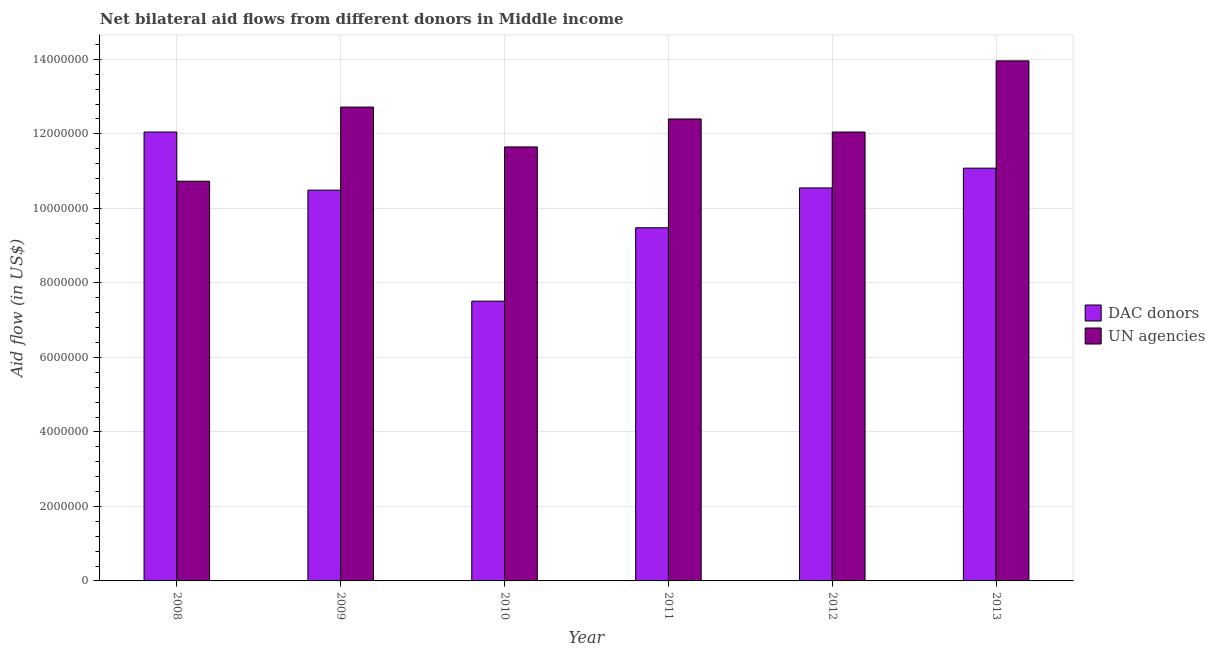Are the number of bars per tick equal to the number of legend labels?
Your answer should be compact. Yes. Are the number of bars on each tick of the X-axis equal?
Make the answer very short. Yes. How many bars are there on the 3rd tick from the left?
Your response must be concise. 2. In how many cases, is the number of bars for a given year not equal to the number of legend labels?
Your answer should be compact. 0. What is the aid flow from dac donors in 2008?
Your response must be concise. 1.20e+07. Across all years, what is the maximum aid flow from un agencies?
Offer a very short reply. 1.40e+07. Across all years, what is the minimum aid flow from dac donors?
Ensure brevity in your answer.  7.51e+06. In which year was the aid flow from un agencies maximum?
Your answer should be compact. 2013. In which year was the aid flow from un agencies minimum?
Provide a succinct answer. 2008. What is the total aid flow from dac donors in the graph?
Your response must be concise. 6.12e+07. What is the difference between the aid flow from un agencies in 2008 and that in 2010?
Offer a very short reply. -9.20e+05. What is the difference between the aid flow from dac donors in 2013 and the aid flow from un agencies in 2012?
Your answer should be very brief. 5.30e+05. What is the average aid flow from un agencies per year?
Provide a succinct answer. 1.23e+07. In the year 2012, what is the difference between the aid flow from dac donors and aid flow from un agencies?
Ensure brevity in your answer.  0. What is the ratio of the aid flow from un agencies in 2011 to that in 2013?
Offer a terse response. 0.89. Is the aid flow from dac donors in 2011 less than that in 2012?
Your response must be concise. Yes. What is the difference between the highest and the second highest aid flow from dac donors?
Provide a succinct answer. 9.70e+05. What is the difference between the highest and the lowest aid flow from dac donors?
Keep it short and to the point. 4.54e+06. In how many years, is the aid flow from dac donors greater than the average aid flow from dac donors taken over all years?
Your response must be concise. 4. Is the sum of the aid flow from un agencies in 2012 and 2013 greater than the maximum aid flow from dac donors across all years?
Offer a terse response. Yes. What does the 2nd bar from the left in 2011 represents?
Offer a terse response. UN agencies. What does the 1st bar from the right in 2009 represents?
Ensure brevity in your answer.  UN agencies. How many bars are there?
Keep it short and to the point. 12. Are all the bars in the graph horizontal?
Your answer should be compact. No. Where does the legend appear in the graph?
Offer a terse response. Center right. How many legend labels are there?
Offer a terse response. 2. What is the title of the graph?
Provide a short and direct response. Net bilateral aid flows from different donors in Middle income. Does "Female population" appear as one of the legend labels in the graph?
Ensure brevity in your answer.  No. What is the label or title of the Y-axis?
Your response must be concise. Aid flow (in US$). What is the Aid flow (in US$) in DAC donors in 2008?
Your answer should be compact. 1.20e+07. What is the Aid flow (in US$) in UN agencies in 2008?
Offer a very short reply. 1.07e+07. What is the Aid flow (in US$) in DAC donors in 2009?
Keep it short and to the point. 1.05e+07. What is the Aid flow (in US$) of UN agencies in 2009?
Provide a short and direct response. 1.27e+07. What is the Aid flow (in US$) in DAC donors in 2010?
Keep it short and to the point. 7.51e+06. What is the Aid flow (in US$) of UN agencies in 2010?
Ensure brevity in your answer.  1.16e+07. What is the Aid flow (in US$) of DAC donors in 2011?
Provide a short and direct response. 9.48e+06. What is the Aid flow (in US$) of UN agencies in 2011?
Offer a very short reply. 1.24e+07. What is the Aid flow (in US$) of DAC donors in 2012?
Give a very brief answer. 1.06e+07. What is the Aid flow (in US$) of UN agencies in 2012?
Provide a succinct answer. 1.20e+07. What is the Aid flow (in US$) in DAC donors in 2013?
Make the answer very short. 1.11e+07. What is the Aid flow (in US$) of UN agencies in 2013?
Ensure brevity in your answer.  1.40e+07. Across all years, what is the maximum Aid flow (in US$) in DAC donors?
Give a very brief answer. 1.20e+07. Across all years, what is the maximum Aid flow (in US$) in UN agencies?
Ensure brevity in your answer.  1.40e+07. Across all years, what is the minimum Aid flow (in US$) in DAC donors?
Provide a succinct answer. 7.51e+06. Across all years, what is the minimum Aid flow (in US$) in UN agencies?
Your response must be concise. 1.07e+07. What is the total Aid flow (in US$) of DAC donors in the graph?
Your answer should be compact. 6.12e+07. What is the total Aid flow (in US$) in UN agencies in the graph?
Keep it short and to the point. 7.35e+07. What is the difference between the Aid flow (in US$) of DAC donors in 2008 and that in 2009?
Offer a terse response. 1.56e+06. What is the difference between the Aid flow (in US$) in UN agencies in 2008 and that in 2009?
Ensure brevity in your answer.  -1.99e+06. What is the difference between the Aid flow (in US$) in DAC donors in 2008 and that in 2010?
Offer a very short reply. 4.54e+06. What is the difference between the Aid flow (in US$) in UN agencies in 2008 and that in 2010?
Offer a very short reply. -9.20e+05. What is the difference between the Aid flow (in US$) of DAC donors in 2008 and that in 2011?
Provide a succinct answer. 2.57e+06. What is the difference between the Aid flow (in US$) of UN agencies in 2008 and that in 2011?
Ensure brevity in your answer.  -1.67e+06. What is the difference between the Aid flow (in US$) of DAC donors in 2008 and that in 2012?
Ensure brevity in your answer.  1.50e+06. What is the difference between the Aid flow (in US$) in UN agencies in 2008 and that in 2012?
Offer a very short reply. -1.32e+06. What is the difference between the Aid flow (in US$) of DAC donors in 2008 and that in 2013?
Provide a short and direct response. 9.70e+05. What is the difference between the Aid flow (in US$) of UN agencies in 2008 and that in 2013?
Provide a short and direct response. -3.23e+06. What is the difference between the Aid flow (in US$) in DAC donors in 2009 and that in 2010?
Keep it short and to the point. 2.98e+06. What is the difference between the Aid flow (in US$) of UN agencies in 2009 and that in 2010?
Offer a terse response. 1.07e+06. What is the difference between the Aid flow (in US$) in DAC donors in 2009 and that in 2011?
Offer a very short reply. 1.01e+06. What is the difference between the Aid flow (in US$) of UN agencies in 2009 and that in 2012?
Keep it short and to the point. 6.70e+05. What is the difference between the Aid flow (in US$) in DAC donors in 2009 and that in 2013?
Ensure brevity in your answer.  -5.90e+05. What is the difference between the Aid flow (in US$) in UN agencies in 2009 and that in 2013?
Your response must be concise. -1.24e+06. What is the difference between the Aid flow (in US$) of DAC donors in 2010 and that in 2011?
Provide a short and direct response. -1.97e+06. What is the difference between the Aid flow (in US$) in UN agencies in 2010 and that in 2011?
Provide a succinct answer. -7.50e+05. What is the difference between the Aid flow (in US$) of DAC donors in 2010 and that in 2012?
Offer a terse response. -3.04e+06. What is the difference between the Aid flow (in US$) in UN agencies in 2010 and that in 2012?
Make the answer very short. -4.00e+05. What is the difference between the Aid flow (in US$) in DAC donors in 2010 and that in 2013?
Keep it short and to the point. -3.57e+06. What is the difference between the Aid flow (in US$) in UN agencies in 2010 and that in 2013?
Your answer should be very brief. -2.31e+06. What is the difference between the Aid flow (in US$) in DAC donors in 2011 and that in 2012?
Make the answer very short. -1.07e+06. What is the difference between the Aid flow (in US$) in UN agencies in 2011 and that in 2012?
Keep it short and to the point. 3.50e+05. What is the difference between the Aid flow (in US$) in DAC donors in 2011 and that in 2013?
Your response must be concise. -1.60e+06. What is the difference between the Aid flow (in US$) in UN agencies in 2011 and that in 2013?
Keep it short and to the point. -1.56e+06. What is the difference between the Aid flow (in US$) in DAC donors in 2012 and that in 2013?
Offer a very short reply. -5.30e+05. What is the difference between the Aid flow (in US$) in UN agencies in 2012 and that in 2013?
Ensure brevity in your answer.  -1.91e+06. What is the difference between the Aid flow (in US$) in DAC donors in 2008 and the Aid flow (in US$) in UN agencies in 2009?
Provide a short and direct response. -6.70e+05. What is the difference between the Aid flow (in US$) of DAC donors in 2008 and the Aid flow (in US$) of UN agencies in 2011?
Provide a succinct answer. -3.50e+05. What is the difference between the Aid flow (in US$) in DAC donors in 2008 and the Aid flow (in US$) in UN agencies in 2012?
Offer a very short reply. 0. What is the difference between the Aid flow (in US$) in DAC donors in 2008 and the Aid flow (in US$) in UN agencies in 2013?
Provide a short and direct response. -1.91e+06. What is the difference between the Aid flow (in US$) of DAC donors in 2009 and the Aid flow (in US$) of UN agencies in 2010?
Your answer should be very brief. -1.16e+06. What is the difference between the Aid flow (in US$) in DAC donors in 2009 and the Aid flow (in US$) in UN agencies in 2011?
Keep it short and to the point. -1.91e+06. What is the difference between the Aid flow (in US$) of DAC donors in 2009 and the Aid flow (in US$) of UN agencies in 2012?
Offer a terse response. -1.56e+06. What is the difference between the Aid flow (in US$) in DAC donors in 2009 and the Aid flow (in US$) in UN agencies in 2013?
Your answer should be very brief. -3.47e+06. What is the difference between the Aid flow (in US$) of DAC donors in 2010 and the Aid flow (in US$) of UN agencies in 2011?
Make the answer very short. -4.89e+06. What is the difference between the Aid flow (in US$) in DAC donors in 2010 and the Aid flow (in US$) in UN agencies in 2012?
Provide a succinct answer. -4.54e+06. What is the difference between the Aid flow (in US$) of DAC donors in 2010 and the Aid flow (in US$) of UN agencies in 2013?
Provide a short and direct response. -6.45e+06. What is the difference between the Aid flow (in US$) of DAC donors in 2011 and the Aid flow (in US$) of UN agencies in 2012?
Provide a short and direct response. -2.57e+06. What is the difference between the Aid flow (in US$) of DAC donors in 2011 and the Aid flow (in US$) of UN agencies in 2013?
Provide a short and direct response. -4.48e+06. What is the difference between the Aid flow (in US$) in DAC donors in 2012 and the Aid flow (in US$) in UN agencies in 2013?
Give a very brief answer. -3.41e+06. What is the average Aid flow (in US$) in DAC donors per year?
Offer a terse response. 1.02e+07. What is the average Aid flow (in US$) of UN agencies per year?
Provide a short and direct response. 1.23e+07. In the year 2008, what is the difference between the Aid flow (in US$) of DAC donors and Aid flow (in US$) of UN agencies?
Offer a terse response. 1.32e+06. In the year 2009, what is the difference between the Aid flow (in US$) in DAC donors and Aid flow (in US$) in UN agencies?
Ensure brevity in your answer.  -2.23e+06. In the year 2010, what is the difference between the Aid flow (in US$) of DAC donors and Aid flow (in US$) of UN agencies?
Offer a very short reply. -4.14e+06. In the year 2011, what is the difference between the Aid flow (in US$) of DAC donors and Aid flow (in US$) of UN agencies?
Make the answer very short. -2.92e+06. In the year 2012, what is the difference between the Aid flow (in US$) in DAC donors and Aid flow (in US$) in UN agencies?
Keep it short and to the point. -1.50e+06. In the year 2013, what is the difference between the Aid flow (in US$) of DAC donors and Aid flow (in US$) of UN agencies?
Provide a short and direct response. -2.88e+06. What is the ratio of the Aid flow (in US$) in DAC donors in 2008 to that in 2009?
Offer a very short reply. 1.15. What is the ratio of the Aid flow (in US$) in UN agencies in 2008 to that in 2009?
Give a very brief answer. 0.84. What is the ratio of the Aid flow (in US$) in DAC donors in 2008 to that in 2010?
Make the answer very short. 1.6. What is the ratio of the Aid flow (in US$) in UN agencies in 2008 to that in 2010?
Offer a terse response. 0.92. What is the ratio of the Aid flow (in US$) of DAC donors in 2008 to that in 2011?
Ensure brevity in your answer.  1.27. What is the ratio of the Aid flow (in US$) of UN agencies in 2008 to that in 2011?
Ensure brevity in your answer.  0.87. What is the ratio of the Aid flow (in US$) of DAC donors in 2008 to that in 2012?
Provide a short and direct response. 1.14. What is the ratio of the Aid flow (in US$) in UN agencies in 2008 to that in 2012?
Provide a short and direct response. 0.89. What is the ratio of the Aid flow (in US$) of DAC donors in 2008 to that in 2013?
Your response must be concise. 1.09. What is the ratio of the Aid flow (in US$) of UN agencies in 2008 to that in 2013?
Provide a short and direct response. 0.77. What is the ratio of the Aid flow (in US$) in DAC donors in 2009 to that in 2010?
Offer a terse response. 1.4. What is the ratio of the Aid flow (in US$) in UN agencies in 2009 to that in 2010?
Your response must be concise. 1.09. What is the ratio of the Aid flow (in US$) in DAC donors in 2009 to that in 2011?
Your response must be concise. 1.11. What is the ratio of the Aid flow (in US$) in UN agencies in 2009 to that in 2011?
Your response must be concise. 1.03. What is the ratio of the Aid flow (in US$) of UN agencies in 2009 to that in 2012?
Make the answer very short. 1.06. What is the ratio of the Aid flow (in US$) of DAC donors in 2009 to that in 2013?
Make the answer very short. 0.95. What is the ratio of the Aid flow (in US$) in UN agencies in 2009 to that in 2013?
Provide a short and direct response. 0.91. What is the ratio of the Aid flow (in US$) of DAC donors in 2010 to that in 2011?
Give a very brief answer. 0.79. What is the ratio of the Aid flow (in US$) in UN agencies in 2010 to that in 2011?
Provide a succinct answer. 0.94. What is the ratio of the Aid flow (in US$) of DAC donors in 2010 to that in 2012?
Your response must be concise. 0.71. What is the ratio of the Aid flow (in US$) of UN agencies in 2010 to that in 2012?
Your answer should be very brief. 0.97. What is the ratio of the Aid flow (in US$) of DAC donors in 2010 to that in 2013?
Make the answer very short. 0.68. What is the ratio of the Aid flow (in US$) of UN agencies in 2010 to that in 2013?
Make the answer very short. 0.83. What is the ratio of the Aid flow (in US$) in DAC donors in 2011 to that in 2012?
Ensure brevity in your answer.  0.9. What is the ratio of the Aid flow (in US$) of UN agencies in 2011 to that in 2012?
Offer a terse response. 1.03. What is the ratio of the Aid flow (in US$) in DAC donors in 2011 to that in 2013?
Offer a very short reply. 0.86. What is the ratio of the Aid flow (in US$) in UN agencies in 2011 to that in 2013?
Give a very brief answer. 0.89. What is the ratio of the Aid flow (in US$) of DAC donors in 2012 to that in 2013?
Provide a succinct answer. 0.95. What is the ratio of the Aid flow (in US$) of UN agencies in 2012 to that in 2013?
Give a very brief answer. 0.86. What is the difference between the highest and the second highest Aid flow (in US$) in DAC donors?
Offer a terse response. 9.70e+05. What is the difference between the highest and the second highest Aid flow (in US$) in UN agencies?
Offer a very short reply. 1.24e+06. What is the difference between the highest and the lowest Aid flow (in US$) in DAC donors?
Make the answer very short. 4.54e+06. What is the difference between the highest and the lowest Aid flow (in US$) of UN agencies?
Make the answer very short. 3.23e+06. 